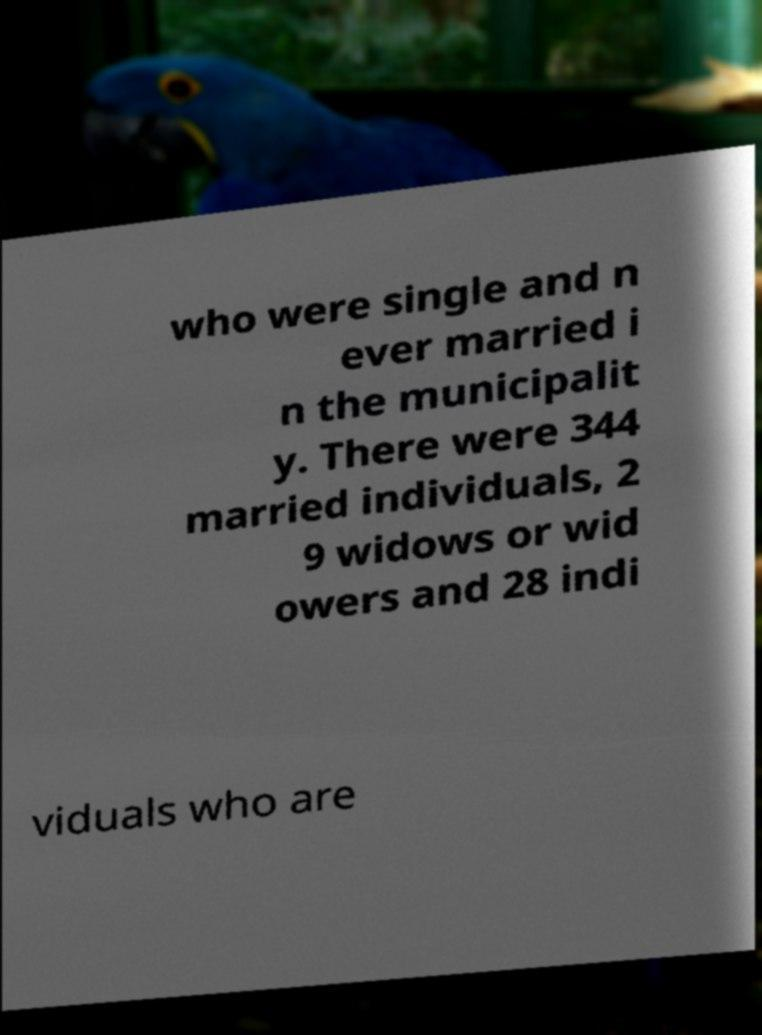There's text embedded in this image that I need extracted. Can you transcribe it verbatim? who were single and n ever married i n the municipalit y. There were 344 married individuals, 2 9 widows or wid owers and 28 indi viduals who are 